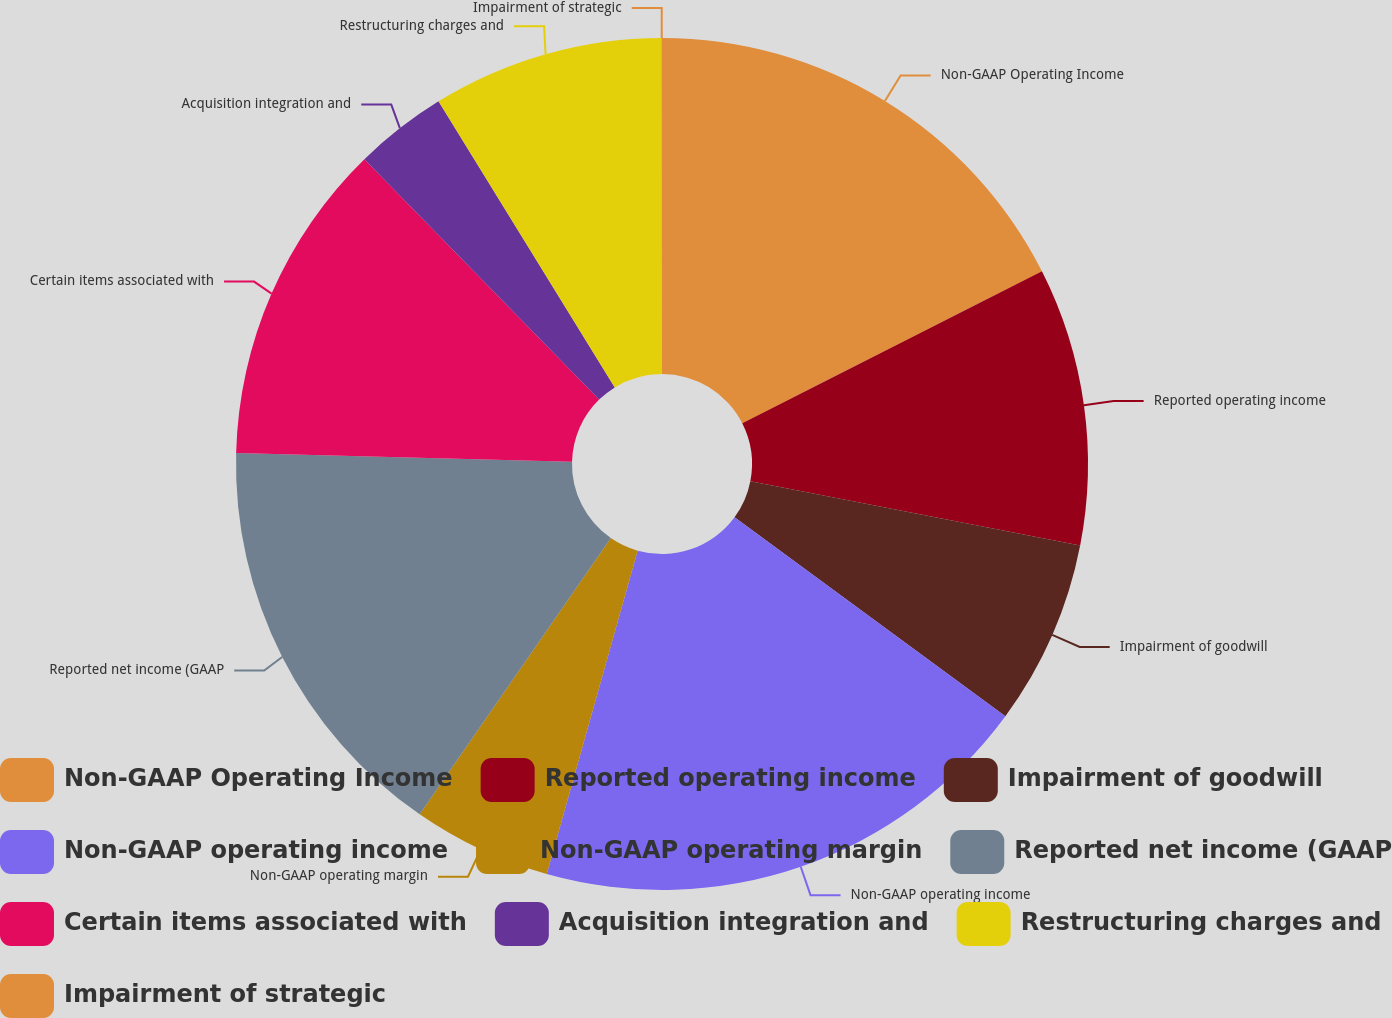Convert chart to OTSL. <chart><loc_0><loc_0><loc_500><loc_500><pie_chart><fcel>Non-GAAP Operating Income<fcel>Reported operating income<fcel>Impairment of goodwill<fcel>Non-GAAP operating income<fcel>Non-GAAP operating margin<fcel>Reported net income (GAAP<fcel>Certain items associated with<fcel>Acquisition integration and<fcel>Restructuring charges and<fcel>Impairment of strategic<nl><fcel>17.53%<fcel>10.53%<fcel>7.02%<fcel>19.28%<fcel>5.27%<fcel>15.78%<fcel>12.28%<fcel>3.52%<fcel>8.77%<fcel>0.02%<nl></chart> 